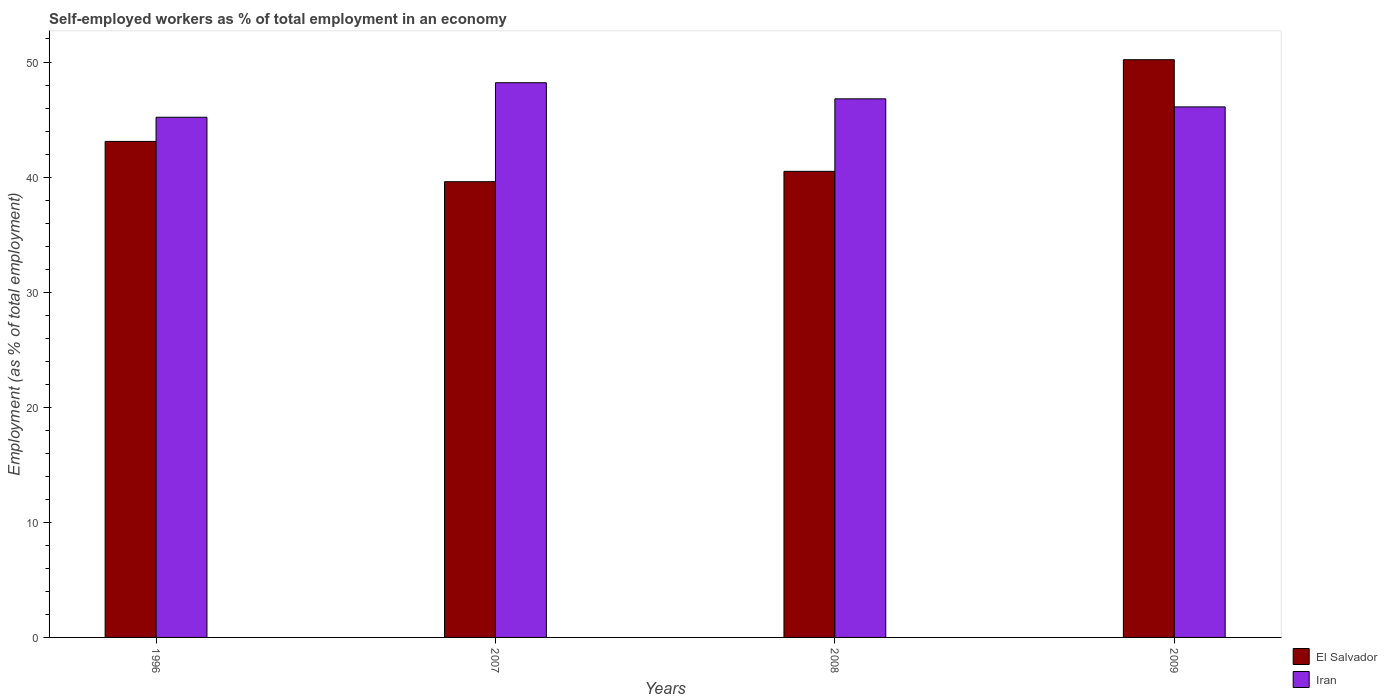How many different coloured bars are there?
Offer a very short reply. 2. Are the number of bars per tick equal to the number of legend labels?
Your answer should be compact. Yes. How many bars are there on the 2nd tick from the left?
Keep it short and to the point. 2. How many bars are there on the 3rd tick from the right?
Your answer should be compact. 2. What is the percentage of self-employed workers in El Salvador in 2008?
Your answer should be compact. 40.5. Across all years, what is the maximum percentage of self-employed workers in El Salvador?
Provide a short and direct response. 50.2. Across all years, what is the minimum percentage of self-employed workers in El Salvador?
Make the answer very short. 39.6. In which year was the percentage of self-employed workers in El Salvador maximum?
Keep it short and to the point. 2009. In which year was the percentage of self-employed workers in El Salvador minimum?
Provide a short and direct response. 2007. What is the total percentage of self-employed workers in El Salvador in the graph?
Your response must be concise. 173.4. What is the difference between the percentage of self-employed workers in Iran in 1996 and that in 2008?
Keep it short and to the point. -1.6. What is the difference between the percentage of self-employed workers in Iran in 2008 and the percentage of self-employed workers in El Salvador in 1996?
Offer a terse response. 3.7. What is the average percentage of self-employed workers in El Salvador per year?
Your response must be concise. 43.35. In the year 2008, what is the difference between the percentage of self-employed workers in El Salvador and percentage of self-employed workers in Iran?
Your answer should be very brief. -6.3. In how many years, is the percentage of self-employed workers in El Salvador greater than 6 %?
Offer a terse response. 4. What is the ratio of the percentage of self-employed workers in El Salvador in 2007 to that in 2008?
Your answer should be very brief. 0.98. Is the percentage of self-employed workers in El Salvador in 2008 less than that in 2009?
Provide a short and direct response. Yes. Is the difference between the percentage of self-employed workers in El Salvador in 1996 and 2008 greater than the difference between the percentage of self-employed workers in Iran in 1996 and 2008?
Offer a terse response. Yes. What is the difference between the highest and the second highest percentage of self-employed workers in El Salvador?
Your answer should be very brief. 7.1. What is the difference between the highest and the lowest percentage of self-employed workers in Iran?
Make the answer very short. 3. In how many years, is the percentage of self-employed workers in El Salvador greater than the average percentage of self-employed workers in El Salvador taken over all years?
Your answer should be compact. 1. Is the sum of the percentage of self-employed workers in Iran in 1996 and 2009 greater than the maximum percentage of self-employed workers in El Salvador across all years?
Ensure brevity in your answer.  Yes. What does the 1st bar from the left in 2007 represents?
Your answer should be very brief. El Salvador. What does the 2nd bar from the right in 2009 represents?
Provide a short and direct response. El Salvador. How many bars are there?
Your response must be concise. 8. How many years are there in the graph?
Your answer should be compact. 4. Does the graph contain any zero values?
Give a very brief answer. No. Does the graph contain grids?
Provide a short and direct response. No. How many legend labels are there?
Offer a very short reply. 2. How are the legend labels stacked?
Offer a terse response. Vertical. What is the title of the graph?
Make the answer very short. Self-employed workers as % of total employment in an economy. What is the label or title of the Y-axis?
Offer a very short reply. Employment (as % of total employment). What is the Employment (as % of total employment) in El Salvador in 1996?
Your answer should be compact. 43.1. What is the Employment (as % of total employment) in Iran in 1996?
Provide a succinct answer. 45.2. What is the Employment (as % of total employment) in El Salvador in 2007?
Provide a succinct answer. 39.6. What is the Employment (as % of total employment) of Iran in 2007?
Keep it short and to the point. 48.2. What is the Employment (as % of total employment) in El Salvador in 2008?
Offer a very short reply. 40.5. What is the Employment (as % of total employment) of Iran in 2008?
Provide a succinct answer. 46.8. What is the Employment (as % of total employment) of El Salvador in 2009?
Provide a short and direct response. 50.2. What is the Employment (as % of total employment) in Iran in 2009?
Your answer should be very brief. 46.1. Across all years, what is the maximum Employment (as % of total employment) in El Salvador?
Keep it short and to the point. 50.2. Across all years, what is the maximum Employment (as % of total employment) in Iran?
Give a very brief answer. 48.2. Across all years, what is the minimum Employment (as % of total employment) of El Salvador?
Your answer should be compact. 39.6. Across all years, what is the minimum Employment (as % of total employment) of Iran?
Your answer should be compact. 45.2. What is the total Employment (as % of total employment) in El Salvador in the graph?
Offer a terse response. 173.4. What is the total Employment (as % of total employment) of Iran in the graph?
Your answer should be very brief. 186.3. What is the difference between the Employment (as % of total employment) of Iran in 1996 and that in 2007?
Offer a very short reply. -3. What is the difference between the Employment (as % of total employment) of Iran in 1996 and that in 2008?
Provide a short and direct response. -1.6. What is the difference between the Employment (as % of total employment) in El Salvador in 1996 and that in 2009?
Your answer should be very brief. -7.1. What is the difference between the Employment (as % of total employment) of El Salvador in 2007 and that in 2008?
Provide a short and direct response. -0.9. What is the difference between the Employment (as % of total employment) of El Salvador in 2007 and that in 2009?
Your response must be concise. -10.6. What is the difference between the Employment (as % of total employment) of El Salvador in 1996 and the Employment (as % of total employment) of Iran in 2007?
Give a very brief answer. -5.1. What is the difference between the Employment (as % of total employment) in El Salvador in 1996 and the Employment (as % of total employment) in Iran in 2009?
Provide a succinct answer. -3. What is the difference between the Employment (as % of total employment) in El Salvador in 2007 and the Employment (as % of total employment) in Iran in 2008?
Ensure brevity in your answer.  -7.2. What is the average Employment (as % of total employment) in El Salvador per year?
Your response must be concise. 43.35. What is the average Employment (as % of total employment) of Iran per year?
Offer a very short reply. 46.58. In the year 2009, what is the difference between the Employment (as % of total employment) in El Salvador and Employment (as % of total employment) in Iran?
Provide a short and direct response. 4.1. What is the ratio of the Employment (as % of total employment) in El Salvador in 1996 to that in 2007?
Keep it short and to the point. 1.09. What is the ratio of the Employment (as % of total employment) of Iran in 1996 to that in 2007?
Your answer should be compact. 0.94. What is the ratio of the Employment (as % of total employment) in El Salvador in 1996 to that in 2008?
Provide a succinct answer. 1.06. What is the ratio of the Employment (as % of total employment) in Iran in 1996 to that in 2008?
Provide a succinct answer. 0.97. What is the ratio of the Employment (as % of total employment) of El Salvador in 1996 to that in 2009?
Keep it short and to the point. 0.86. What is the ratio of the Employment (as % of total employment) of Iran in 1996 to that in 2009?
Offer a terse response. 0.98. What is the ratio of the Employment (as % of total employment) of El Salvador in 2007 to that in 2008?
Give a very brief answer. 0.98. What is the ratio of the Employment (as % of total employment) in Iran in 2007 to that in 2008?
Ensure brevity in your answer.  1.03. What is the ratio of the Employment (as % of total employment) in El Salvador in 2007 to that in 2009?
Provide a short and direct response. 0.79. What is the ratio of the Employment (as % of total employment) of Iran in 2007 to that in 2009?
Ensure brevity in your answer.  1.05. What is the ratio of the Employment (as % of total employment) of El Salvador in 2008 to that in 2009?
Give a very brief answer. 0.81. What is the ratio of the Employment (as % of total employment) in Iran in 2008 to that in 2009?
Offer a terse response. 1.02. What is the difference between the highest and the second highest Employment (as % of total employment) of El Salvador?
Offer a very short reply. 7.1. What is the difference between the highest and the lowest Employment (as % of total employment) of Iran?
Your response must be concise. 3. 